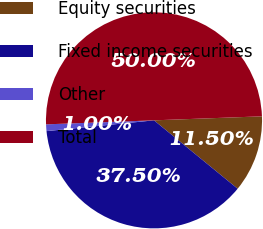<chart> <loc_0><loc_0><loc_500><loc_500><pie_chart><fcel>Equity securities<fcel>Fixed income securities<fcel>Other<fcel>Total<nl><fcel>11.5%<fcel>37.5%<fcel>1.0%<fcel>50.0%<nl></chart> 